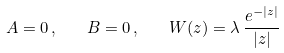Convert formula to latex. <formula><loc_0><loc_0><loc_500><loc_500>A = 0 \, , \quad B = 0 \, , \quad W ( z ) = \lambda \, \frac { e ^ { - | z | } } { | z | }</formula> 